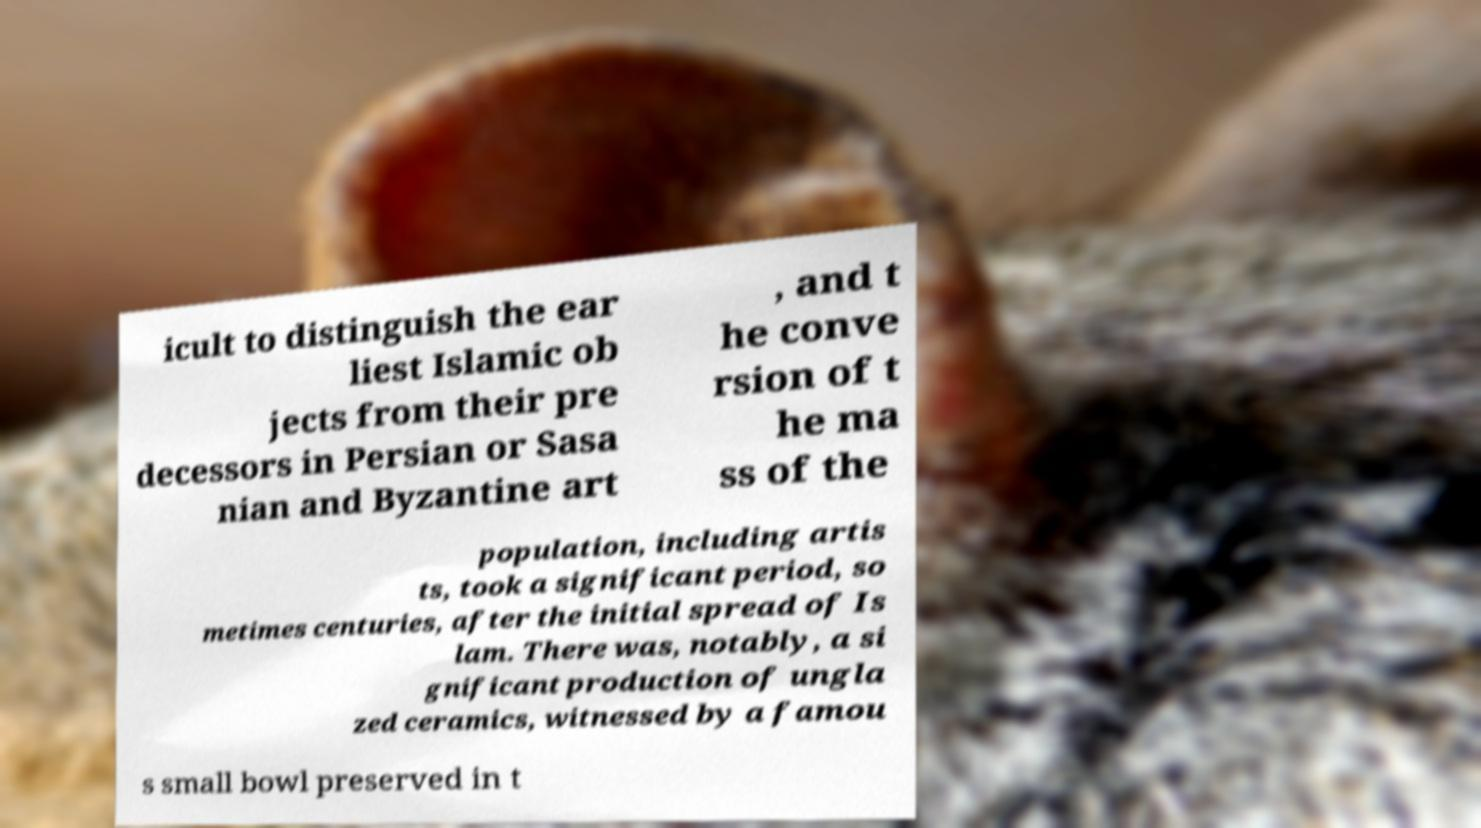There's text embedded in this image that I need extracted. Can you transcribe it verbatim? icult to distinguish the ear liest Islamic ob jects from their pre decessors in Persian or Sasa nian and Byzantine art , and t he conve rsion of t he ma ss of the population, including artis ts, took a significant period, so metimes centuries, after the initial spread of Is lam. There was, notably, a si gnificant production of ungla zed ceramics, witnessed by a famou s small bowl preserved in t 